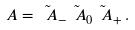Convert formula to latex. <formula><loc_0><loc_0><loc_500><loc_500>\ A = \tilde { \ A } _ { - } \tilde { \ A } _ { 0 } \tilde { \ A } _ { + } \, .</formula> 